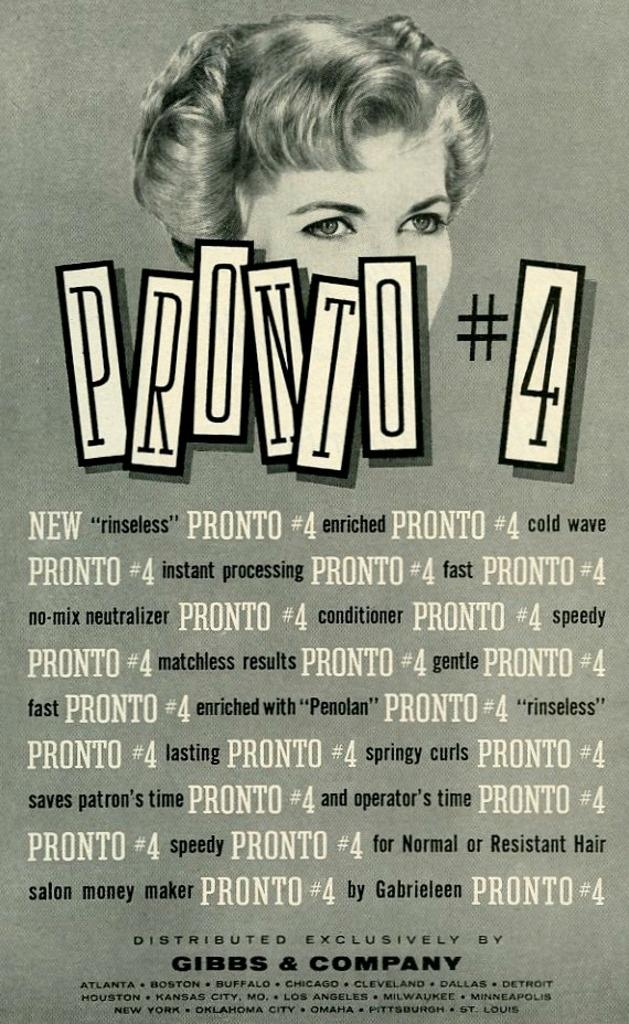<image>
Present a compact description of the photo's key features. an advertisement with pronto   number 4 on it a gray background 